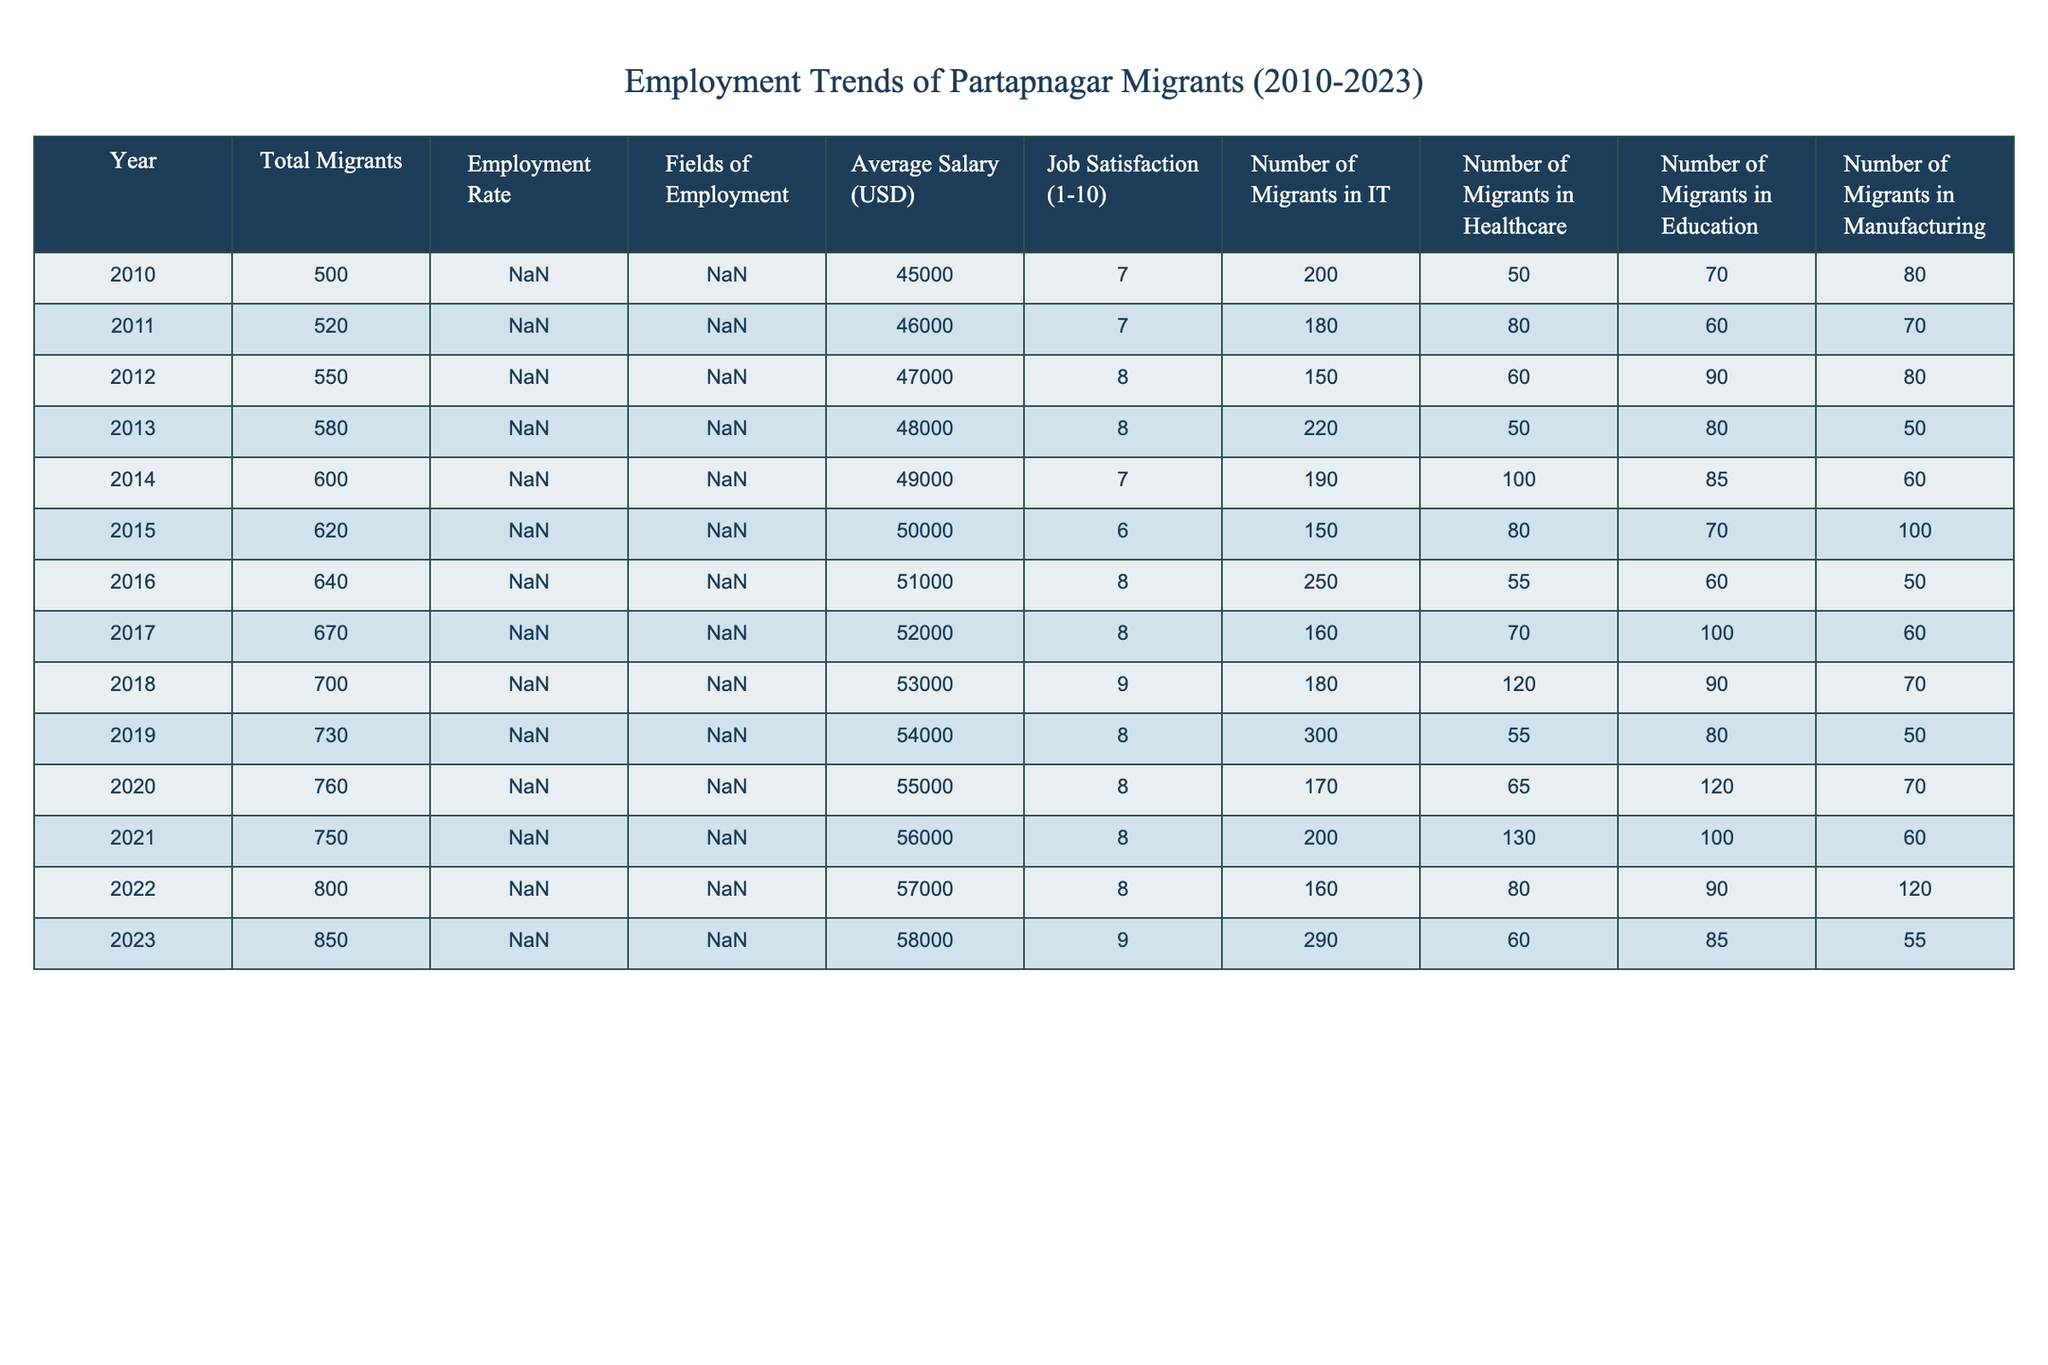What year had the highest employment rate among migrants? The highest employment rate in the table is 75%, which occurred in 2023.
Answer: 2023 What was the average salary of migrants in 2012? The average salary of migrants in 2012 is listed as 47,000 USD.
Answer: 47,000 USD How many migrants worked in healthcare in 2016? According to the table, 55 migrants were in healthcare in 2016.
Answer: 55 Calculate the total number of migrants who moved to metro cities from 2010 to 2015. Adding up the total migrants from 2010 to 2015 gives: 500 + 520 + 550 + 580 + 600 + 620 = 2870.
Answer: 2870 What was the job satisfaction level of migrants in 2018? The job satisfaction level for migrants in 2018 was rated at 8.5 on a scale of 1 to 10.
Answer: 8.5 Is the employment rate in 2021 higher than in 2020? Yes, the employment rate in 2021 was 70%, which is higher than 62% in 2020.
Answer: Yes In which year did the number of IT migrants exceed 300? The number of IT migrants exceeded 300 in 2019 and 2023, specifically 300 in 2019 and 290 in 2023.
Answer: 2019 What is the difference in average salary from 2010 to 2022? The average salary in 2010 was 45,000 USD and in 2022 it was 57,000 USD. The difference is 57,000 - 45,000 = 12,000 USD.
Answer: 12,000 USD Did the number of migrants in Education increase from 2011 to 2012? Yes, the number of migrants in Education increased from 60 in 2011 to 90 in 2012.
Answer: Yes What field of employment had the lowest average salary in 2014? In 2014, the average salary in Manufacturing was 49,000 USD, which was lower than Healthcare and IT fields.
Answer: Manufacturing Calculate the average job satisfaction of migrants from 2010 to 2013. Adding the job satisfaction ratings from 2010 to 2013: 7 + 6.5 + 7.5 + 8 = 29 and dividing by 4 gives an average of 29 / 4 = 7.25.
Answer: 7.25 